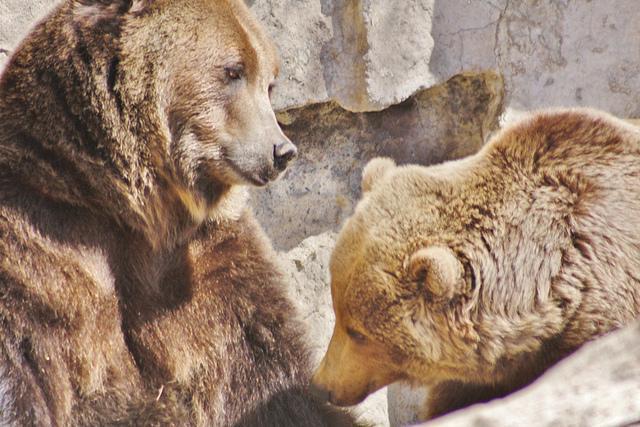How many bears are here?
Give a very brief answer. 2. How many bears can you see?
Give a very brief answer. 2. 